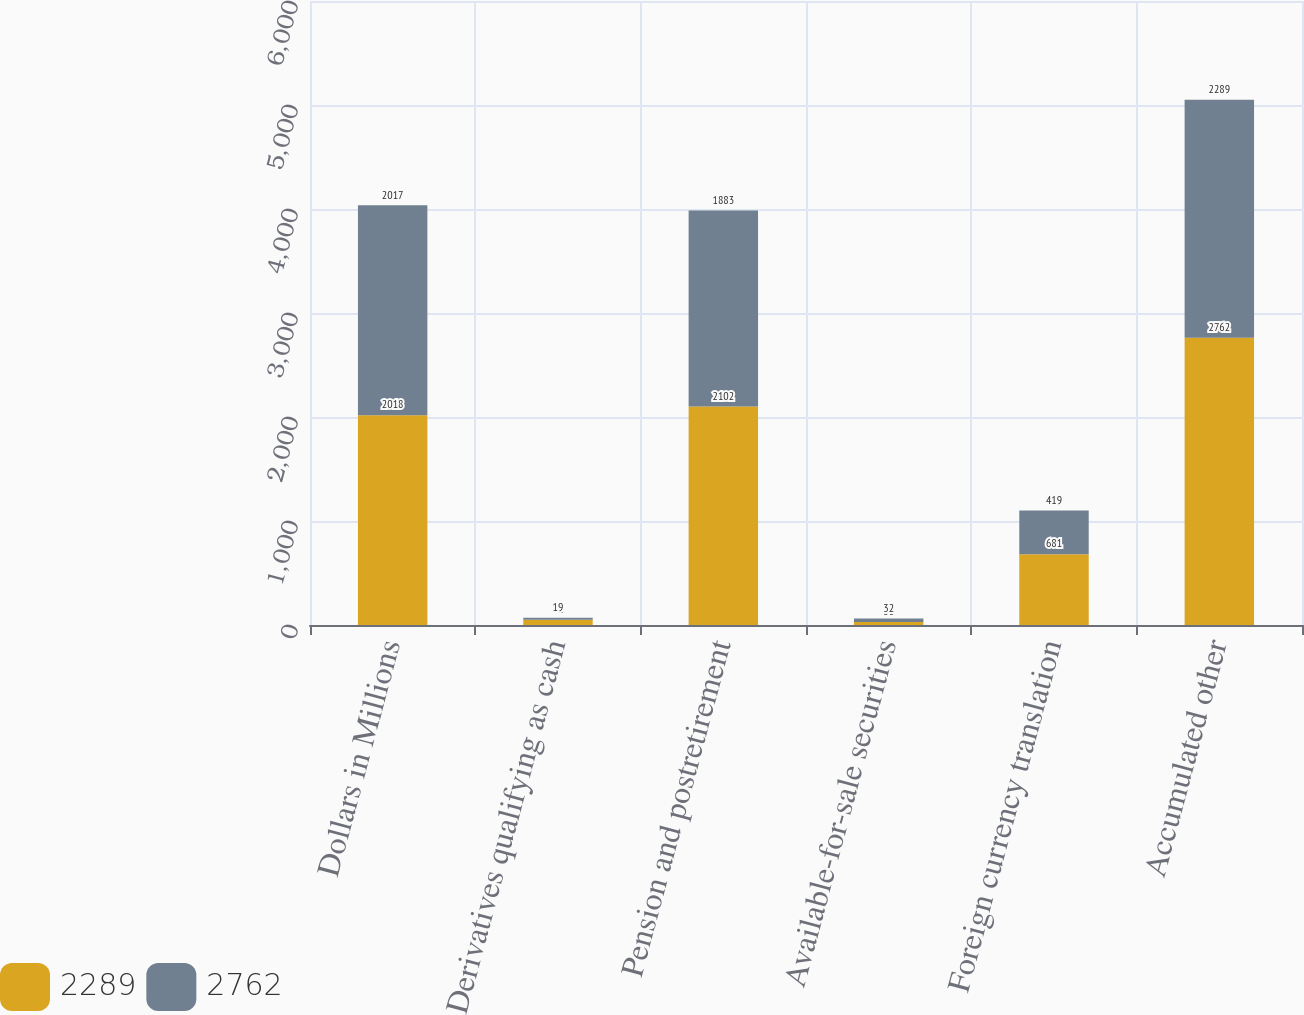<chart> <loc_0><loc_0><loc_500><loc_500><stacked_bar_chart><ecel><fcel>Dollars in Millions<fcel>Derivatives qualifying as cash<fcel>Pension and postretirement<fcel>Available-for-sale securities<fcel>Foreign currency translation<fcel>Accumulated other<nl><fcel>2289<fcel>2018<fcel>51<fcel>2102<fcel>30<fcel>681<fcel>2762<nl><fcel>2762<fcel>2017<fcel>19<fcel>1883<fcel>32<fcel>419<fcel>2289<nl></chart> 